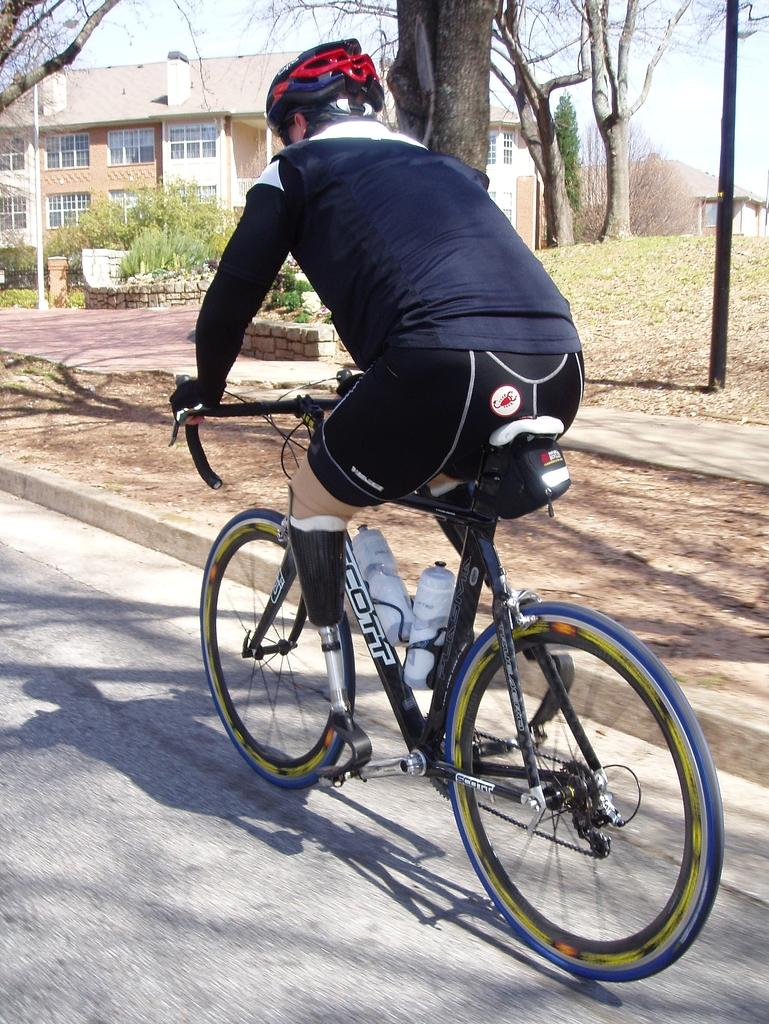What is the person in the image doing? There is a person riding a bicycle in the image. What can be seen in the image besides the person on the bicycle? There are poles, grass, trees, and a building in the background visible in the image. How many eggs are being caught in the net in the image? There are no eggs or nets present in the image. What type of bee can be seen flying around the person on the bicycle? There are no bees visible in the image. 